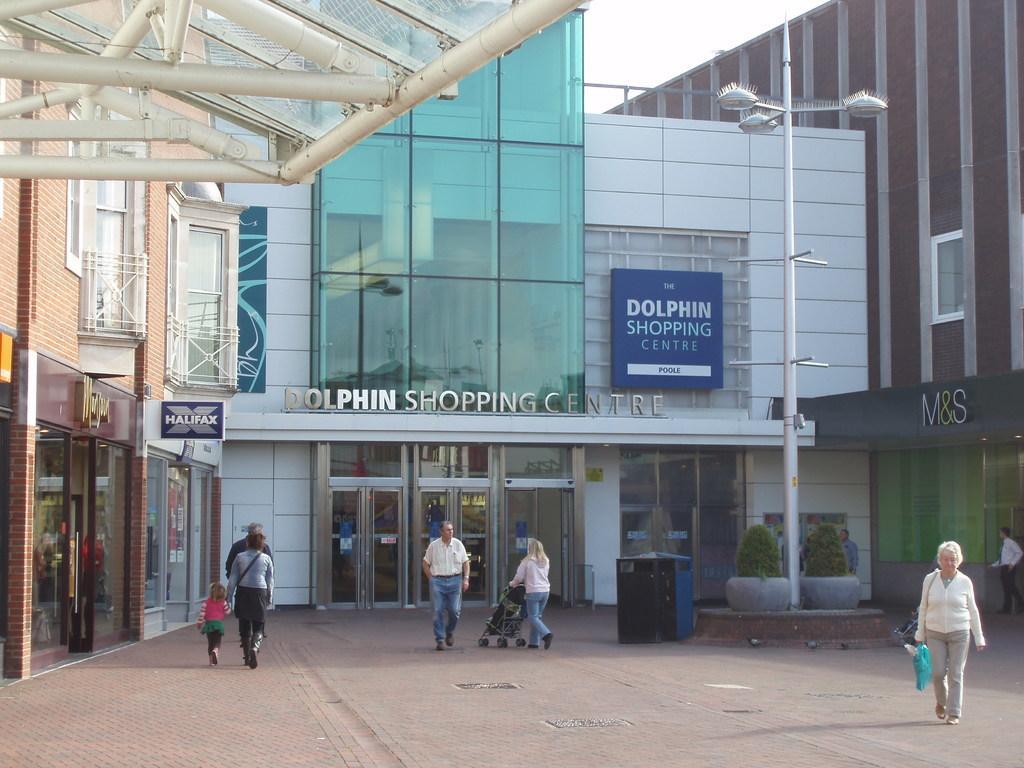Please provide a concise description of this image. In the image we can see that there are many people wearing clothes and they are walking. This is a footpath, light pole, building, roof, fence, text, board, plants and a white sky. 